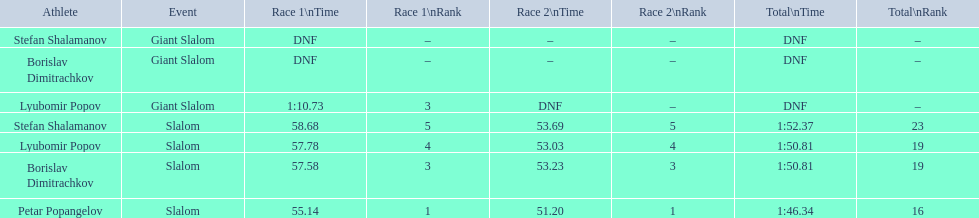Which athletes had consecutive times under 58 for both races? Lyubomir Popov, Borislav Dimitrachkov, Petar Popangelov. 